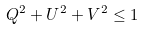Convert formula to latex. <formula><loc_0><loc_0><loc_500><loc_500>Q ^ { 2 } + U ^ { 2 } + V ^ { 2 } \leq 1</formula> 